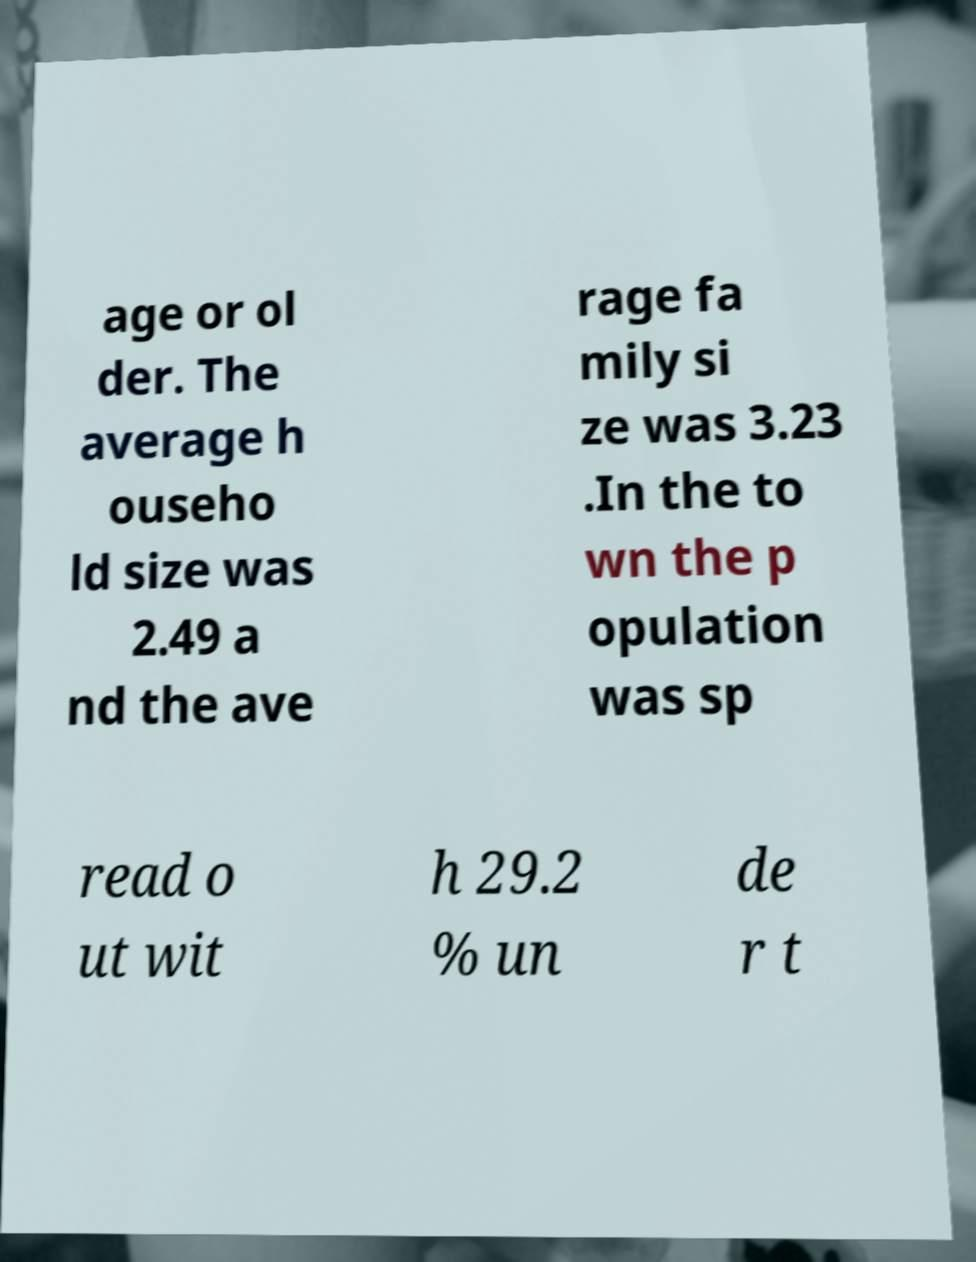Could you assist in decoding the text presented in this image and type it out clearly? age or ol der. The average h ouseho ld size was 2.49 a nd the ave rage fa mily si ze was 3.23 .In the to wn the p opulation was sp read o ut wit h 29.2 % un de r t 